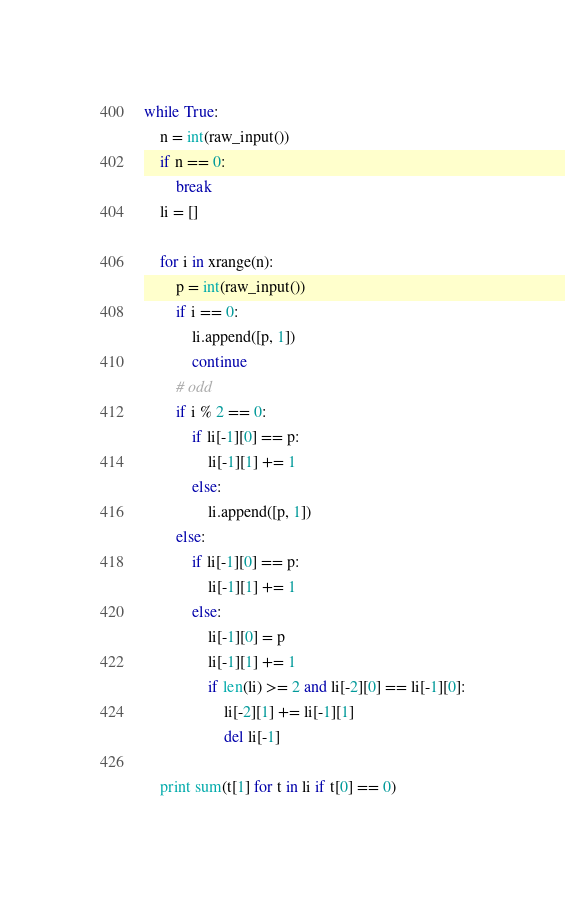<code> <loc_0><loc_0><loc_500><loc_500><_Python_>while True:
    n = int(raw_input())
    if n == 0:
        break
    li = []

    for i in xrange(n):
        p = int(raw_input())
        if i == 0:
            li.append([p, 1])
            continue
        # odd
        if i % 2 == 0:
            if li[-1][0] == p:
                li[-1][1] += 1
            else:
                li.append([p, 1])
        else:
            if li[-1][0] == p:
                li[-1][1] += 1
            else:
                li[-1][0] = p
                li[-1][1] += 1
                if len(li) >= 2 and li[-2][0] == li[-1][0]:
                    li[-2][1] += li[-1][1]
                    del li[-1]

    print sum(t[1] for t in li if t[0] == 0)</code> 